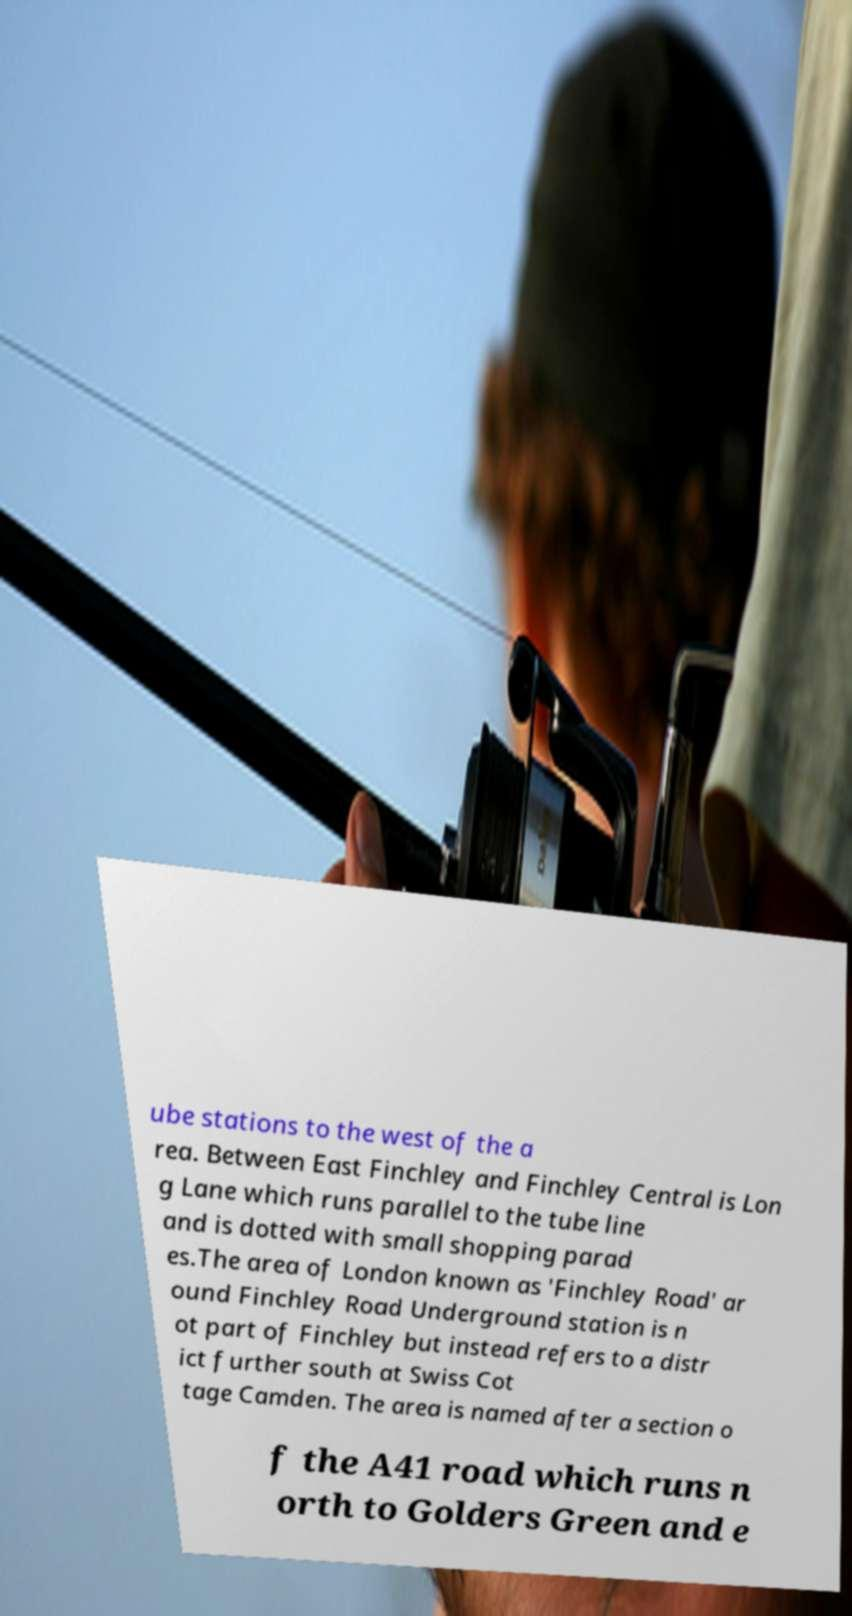For documentation purposes, I need the text within this image transcribed. Could you provide that? ube stations to the west of the a rea. Between East Finchley and Finchley Central is Lon g Lane which runs parallel to the tube line and is dotted with small shopping parad es.The area of London known as 'Finchley Road' ar ound Finchley Road Underground station is n ot part of Finchley but instead refers to a distr ict further south at Swiss Cot tage Camden. The area is named after a section o f the A41 road which runs n orth to Golders Green and e 